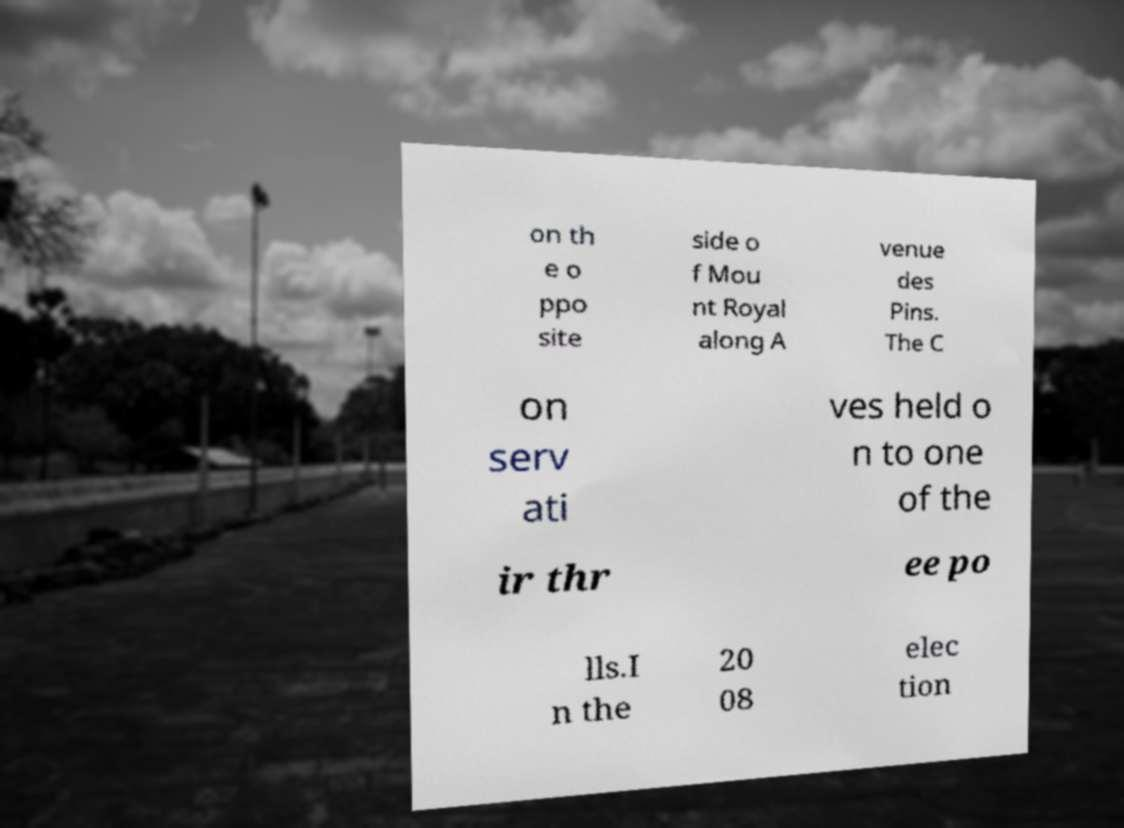There's text embedded in this image that I need extracted. Can you transcribe it verbatim? on th e o ppo site side o f Mou nt Royal along A venue des Pins. The C on serv ati ves held o n to one of the ir thr ee po lls.I n the 20 08 elec tion 